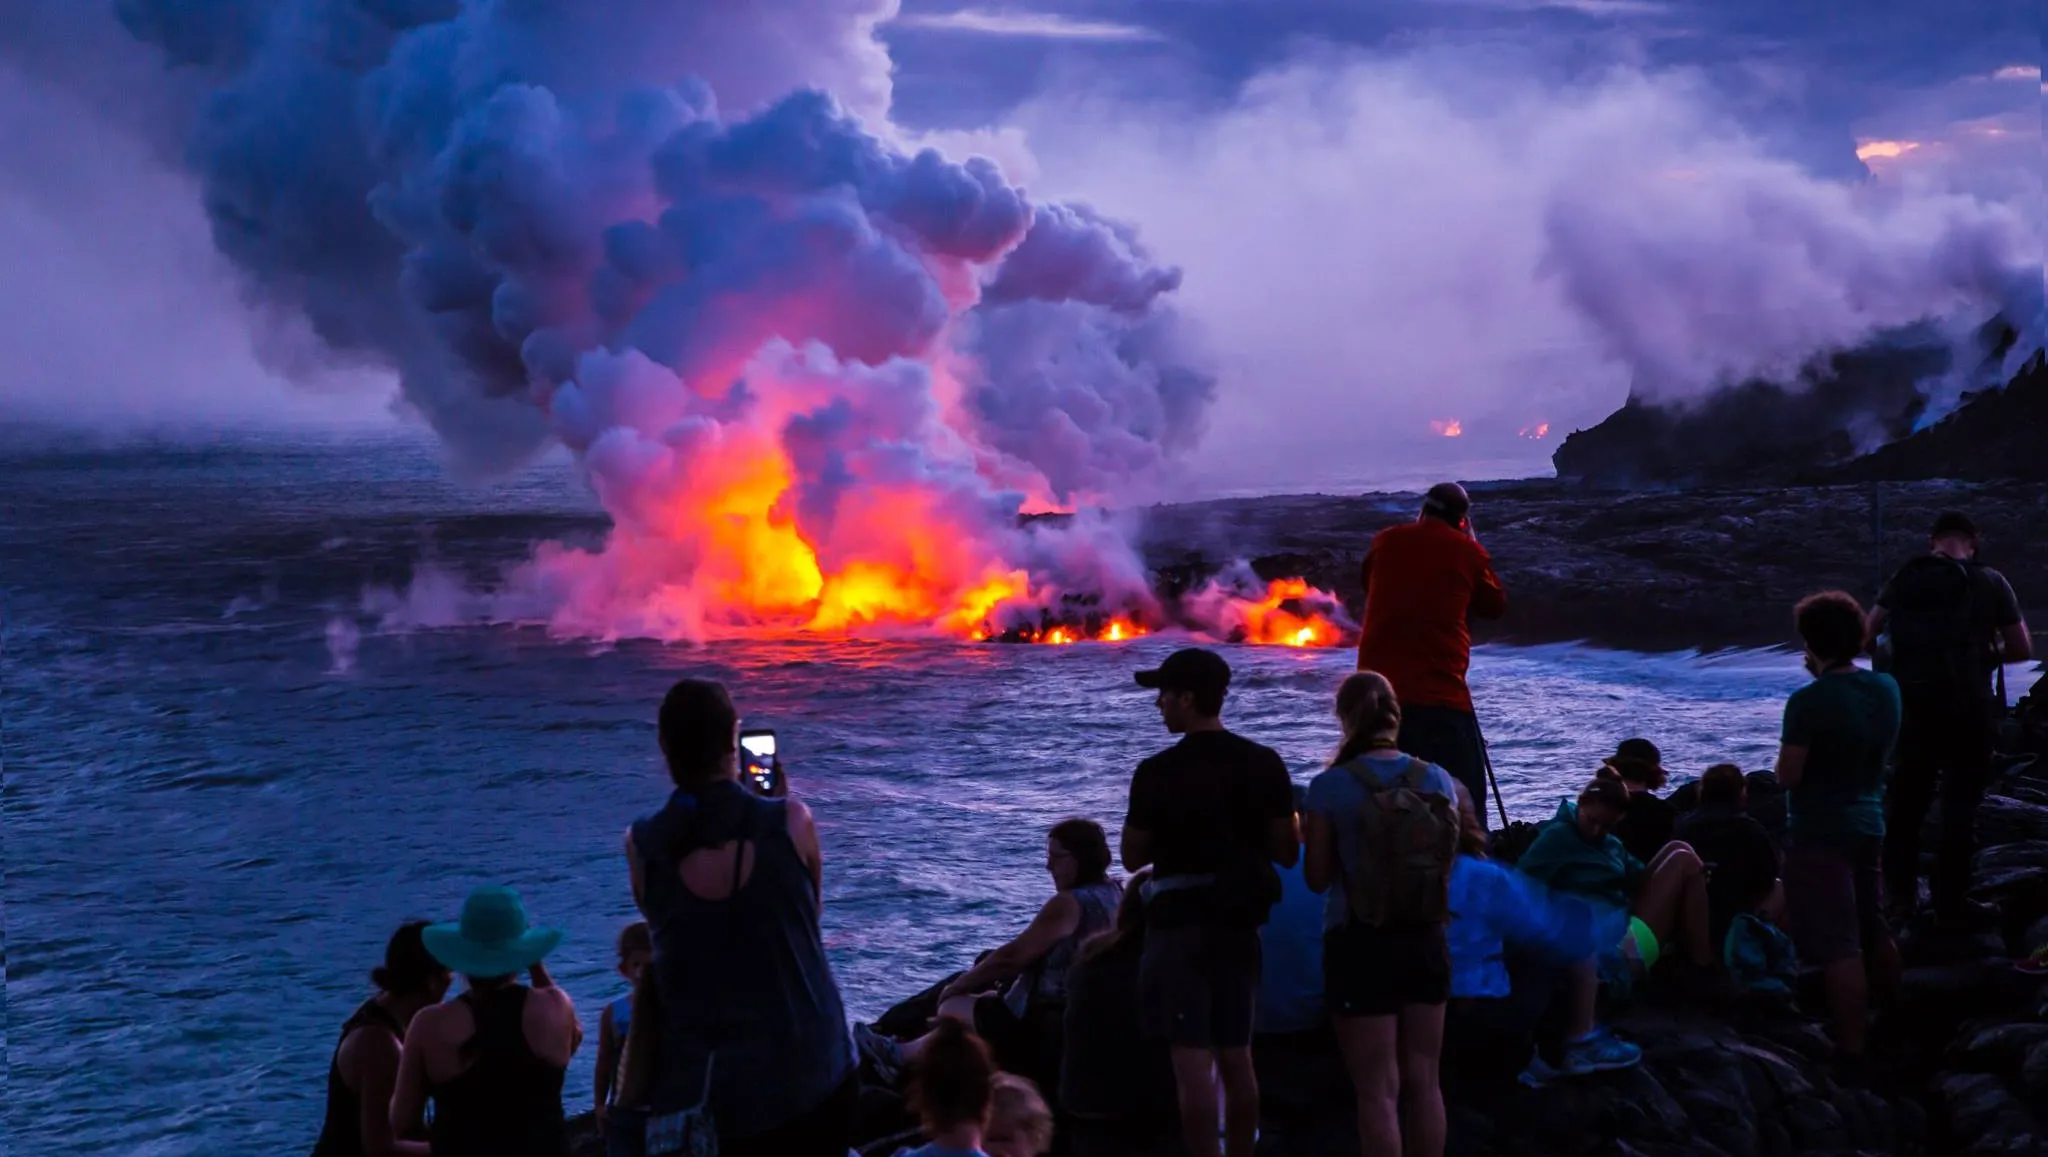What impact does such an eruption have on the local wildlife? Volcanic eruptions can significantly affect local wildlife, leading to habitat destruction from lava flows and ash deposits. Aquatic life could be impacted by changes in water temperature and chemistry due to the lava entering the ocean. However, new habitats may eventually form as the area recovers, offering new opportunities for wildlife adaptation and biodiversity. 